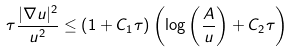Convert formula to latex. <formula><loc_0><loc_0><loc_500><loc_500>\tau \frac { | \nabla u | ^ { 2 } } { u ^ { 2 } } \leq \left ( 1 + C _ { 1 } \tau \right ) \left ( \log \left ( \frac { A } { u } \right ) + C _ { 2 } \tau \right )</formula> 